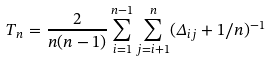<formula> <loc_0><loc_0><loc_500><loc_500>T _ { n } = \frac { 2 } { n ( n - 1 ) } \sum _ { i = 1 } ^ { n - 1 } \sum _ { j = i + 1 } ^ { n } ( \Delta _ { i j } + 1 / n ) ^ { - 1 }</formula> 